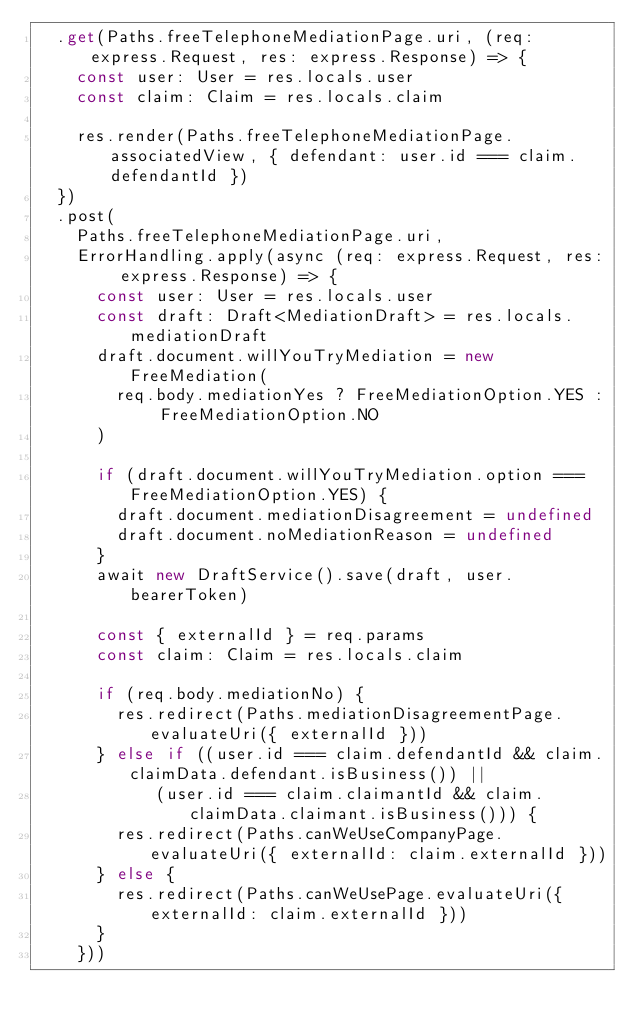Convert code to text. <code><loc_0><loc_0><loc_500><loc_500><_TypeScript_>  .get(Paths.freeTelephoneMediationPage.uri, (req: express.Request, res: express.Response) => {
    const user: User = res.locals.user
    const claim: Claim = res.locals.claim

    res.render(Paths.freeTelephoneMediationPage.associatedView, { defendant: user.id === claim.defendantId })
  })
  .post(
    Paths.freeTelephoneMediationPage.uri,
    ErrorHandling.apply(async (req: express.Request, res: express.Response) => {
      const user: User = res.locals.user
      const draft: Draft<MediationDraft> = res.locals.mediationDraft
      draft.document.willYouTryMediation = new FreeMediation(
        req.body.mediationYes ? FreeMediationOption.YES : FreeMediationOption.NO
      )

      if (draft.document.willYouTryMediation.option === FreeMediationOption.YES) {
        draft.document.mediationDisagreement = undefined
        draft.document.noMediationReason = undefined
      }
      await new DraftService().save(draft, user.bearerToken)

      const { externalId } = req.params
      const claim: Claim = res.locals.claim

      if (req.body.mediationNo) {
        res.redirect(Paths.mediationDisagreementPage.evaluateUri({ externalId }))
      } else if ((user.id === claim.defendantId && claim.claimData.defendant.isBusiness()) ||
            (user.id === claim.claimantId && claim.claimData.claimant.isBusiness())) {
        res.redirect(Paths.canWeUseCompanyPage.evaluateUri({ externalId: claim.externalId }))
      } else {
        res.redirect(Paths.canWeUsePage.evaluateUri({ externalId: claim.externalId }))
      }
    }))
</code> 